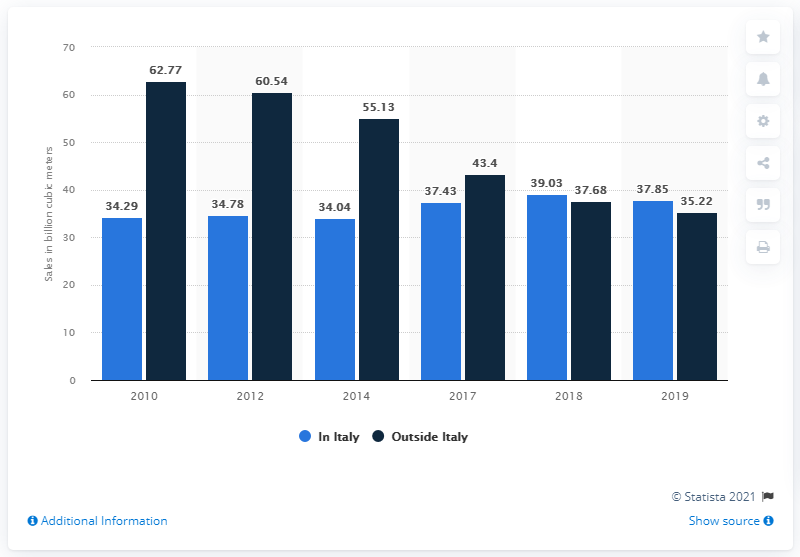Give some essential details in this illustration. The ratio between data collected in Italy and data collected outside of Italy is 1.111111111... In 2017, the value outside of Italy was 43.4. Eni Sp.A. had 37.85 cubic meters of gas sales in Italy in 2019. 